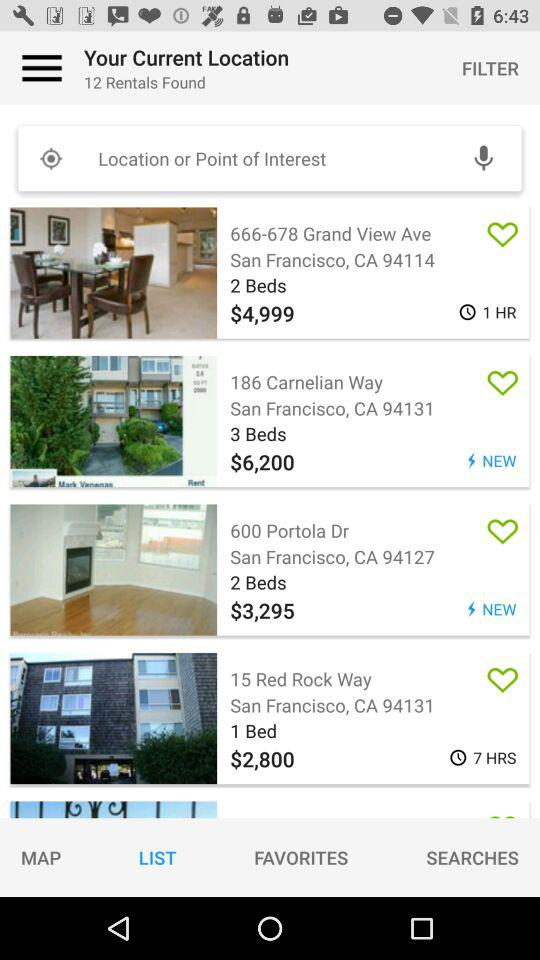How many rentals have a price of less than $5,000?
Answer the question using a single word or phrase. 3 